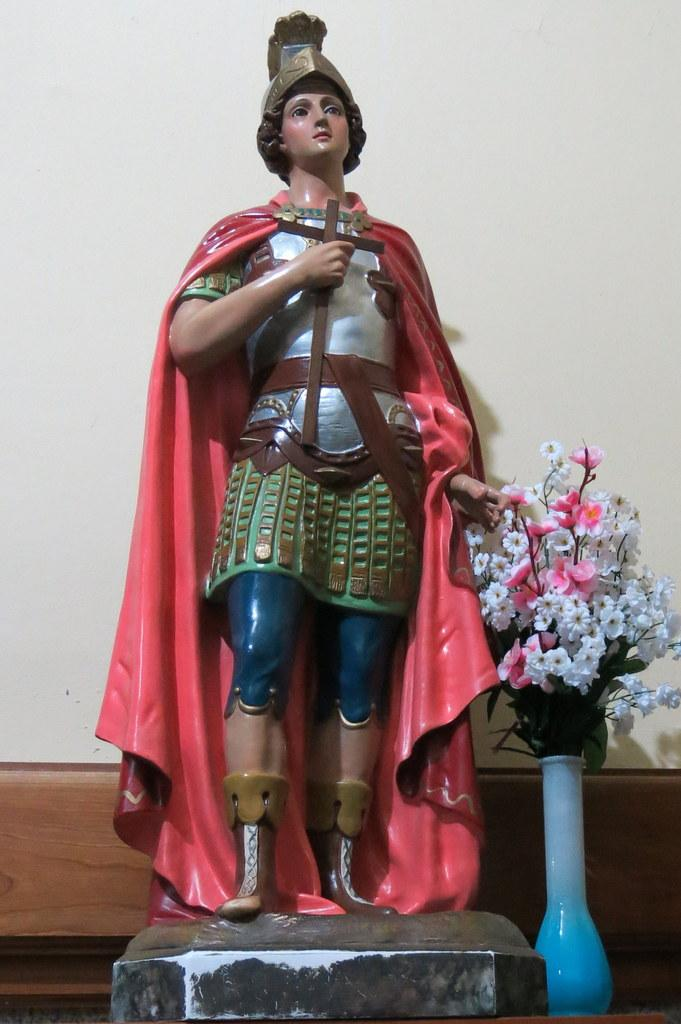What is the main subject of the image? There is a statue of a person in the image. What else can be seen in the image besides the statue? There is a flower vase in the image. What type of flowers are in the vase? There are artificial flowers in the vase. What is located at the back of the image? There is a wall at the back of the image. Can you tell me how many potatoes are on the statue's head in the image? There are no potatoes present in the image; the statue is of a person with no potatoes on its head. 